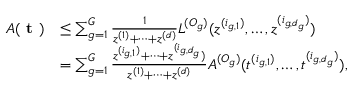<formula> <loc_0><loc_0><loc_500><loc_500>\begin{array} { r l } { A ( t ) } & { \leq \sum _ { g = 1 } ^ { G } \frac { 1 } { z ^ { ( 1 ) } + \dots + z ^ { ( d ) } } L ^ { ( O _ { g } ) } ( z ^ { ( i _ { g , 1 } ) } , \dots , z ^ { ( i _ { g , d _ { g } } ) } ) } \\ & { = \sum _ { g = 1 } ^ { G } \frac { z ^ { ( i _ { g , 1 } ) } + \dots + z ^ { ( i _ { g , d _ { g } } } ) } { z ^ { ( 1 ) } + \dots + z ^ { ( d ) } } A ^ { ( O _ { g } ) } ( t ^ { ( i _ { g , 1 } ) } , \dots , t ^ { ( i _ { g , d _ { g } } ) } ) , } \end{array}</formula> 